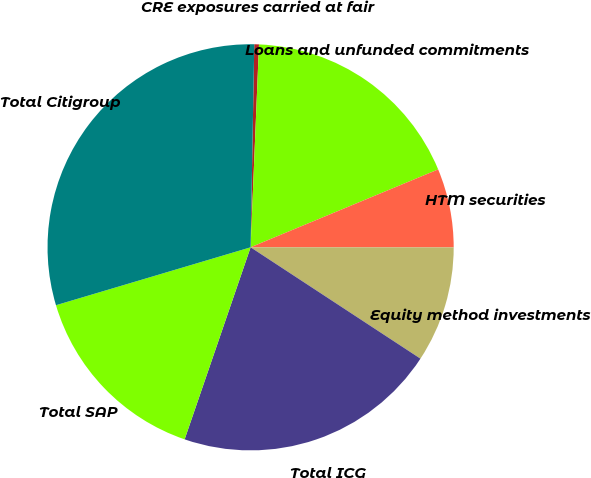Convert chart. <chart><loc_0><loc_0><loc_500><loc_500><pie_chart><fcel>CRE exposures carried at fair<fcel>Loans and unfunded commitments<fcel>HTM securities<fcel>Equity method investments<fcel>Total ICG<fcel>Total SAP<fcel>Total Citigroup<nl><fcel>0.37%<fcel>18.08%<fcel>6.27%<fcel>9.23%<fcel>21.03%<fcel>15.13%<fcel>29.89%<nl></chart> 